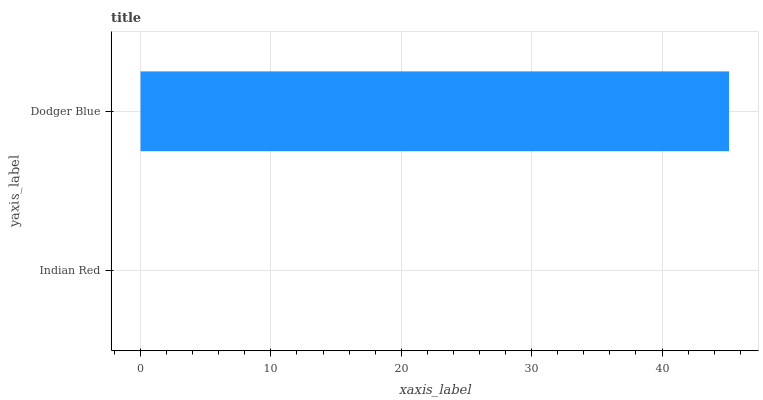Is Indian Red the minimum?
Answer yes or no. Yes. Is Dodger Blue the maximum?
Answer yes or no. Yes. Is Dodger Blue the minimum?
Answer yes or no. No. Is Dodger Blue greater than Indian Red?
Answer yes or no. Yes. Is Indian Red less than Dodger Blue?
Answer yes or no. Yes. Is Indian Red greater than Dodger Blue?
Answer yes or no. No. Is Dodger Blue less than Indian Red?
Answer yes or no. No. Is Dodger Blue the high median?
Answer yes or no. Yes. Is Indian Red the low median?
Answer yes or no. Yes. Is Indian Red the high median?
Answer yes or no. No. Is Dodger Blue the low median?
Answer yes or no. No. 